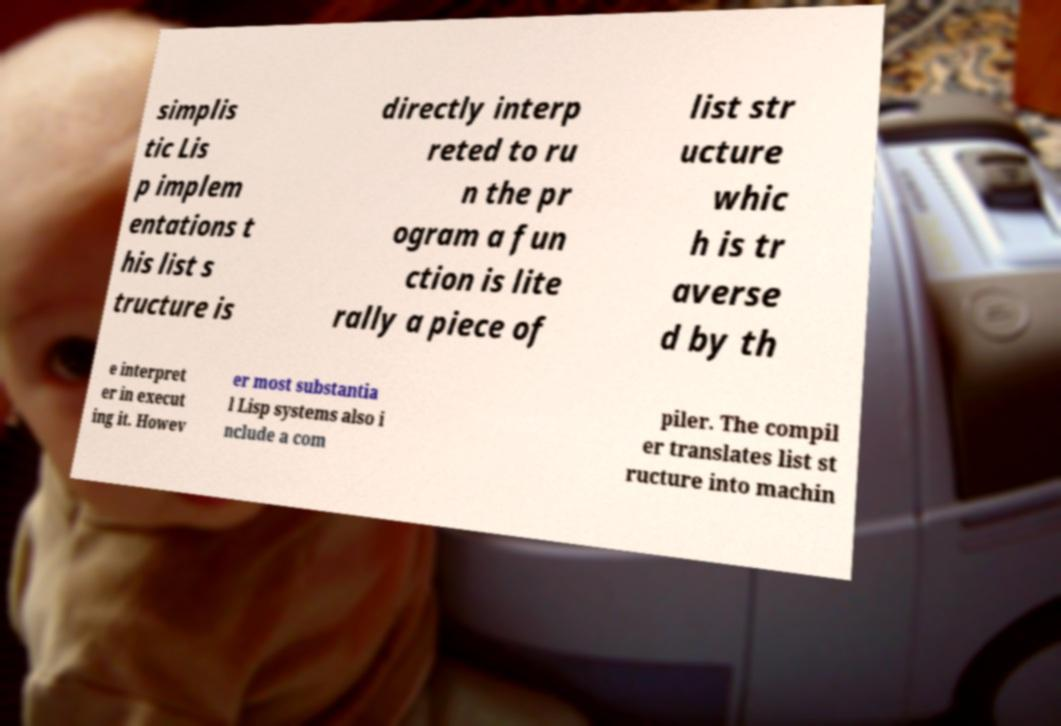Could you assist in decoding the text presented in this image and type it out clearly? simplis tic Lis p implem entations t his list s tructure is directly interp reted to ru n the pr ogram a fun ction is lite rally a piece of list str ucture whic h is tr averse d by th e interpret er in execut ing it. Howev er most substantia l Lisp systems also i nclude a com piler. The compil er translates list st ructure into machin 